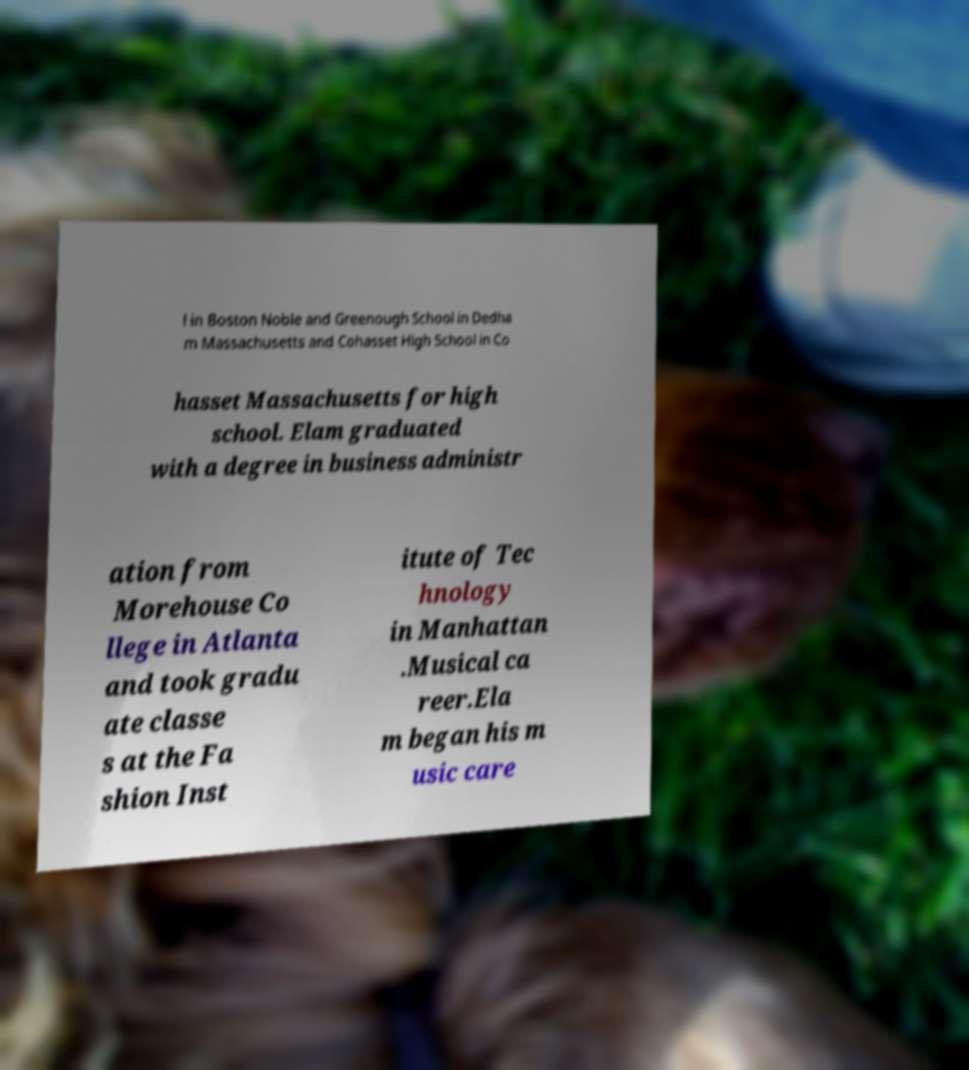Please identify and transcribe the text found in this image. l in Boston Noble and Greenough School in Dedha m Massachusetts and Cohasset High School in Co hasset Massachusetts for high school. Elam graduated with a degree in business administr ation from Morehouse Co llege in Atlanta and took gradu ate classe s at the Fa shion Inst itute of Tec hnology in Manhattan .Musical ca reer.Ela m began his m usic care 